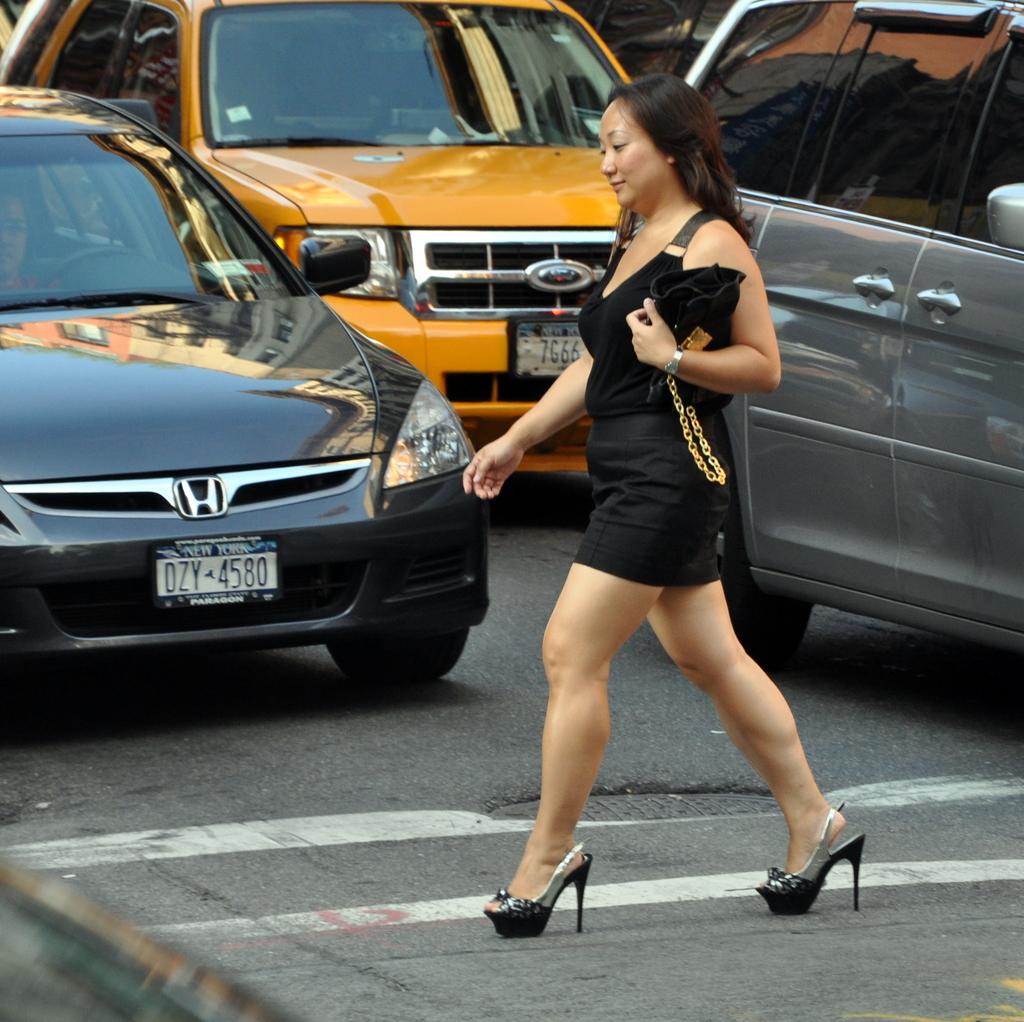What is the license plate on the black car?
Provide a short and direct response. Dzy 4580. 